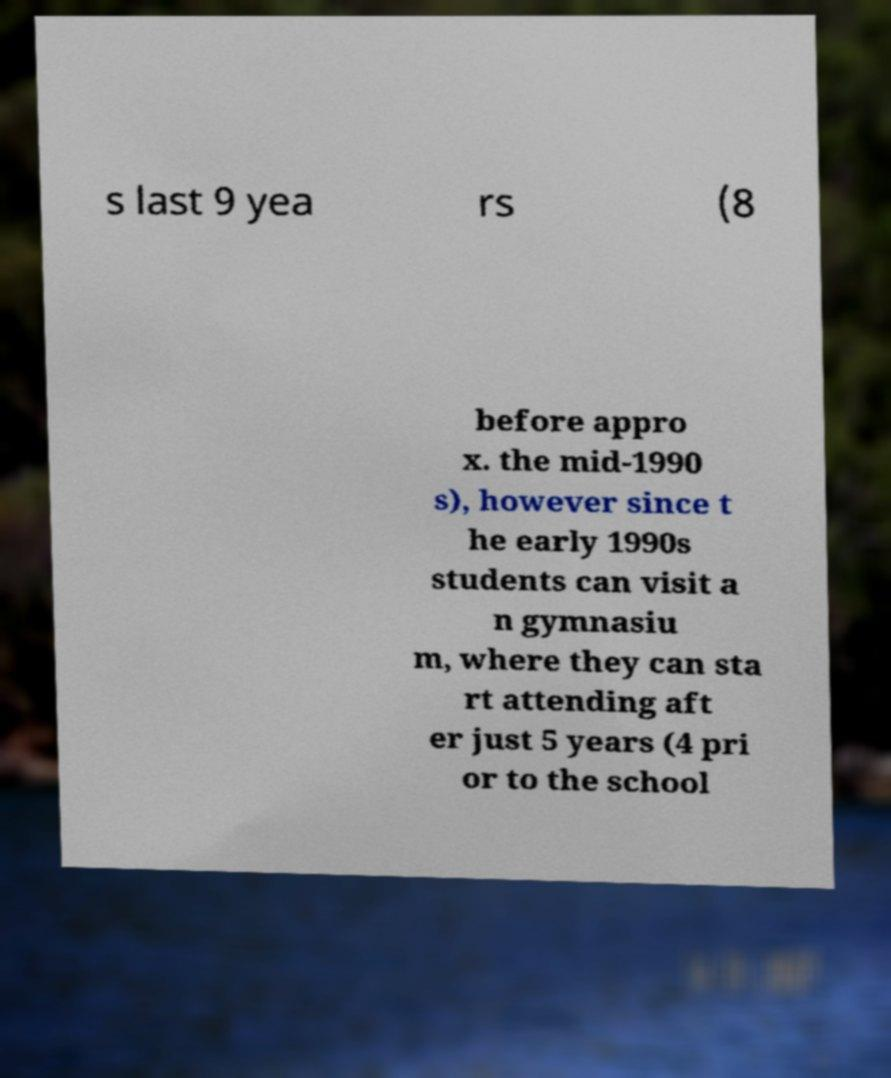Please read and relay the text visible in this image. What does it say? s last 9 yea rs (8 before appro x. the mid-1990 s), however since t he early 1990s students can visit a n gymnasiu m, where they can sta rt attending aft er just 5 years (4 pri or to the school 